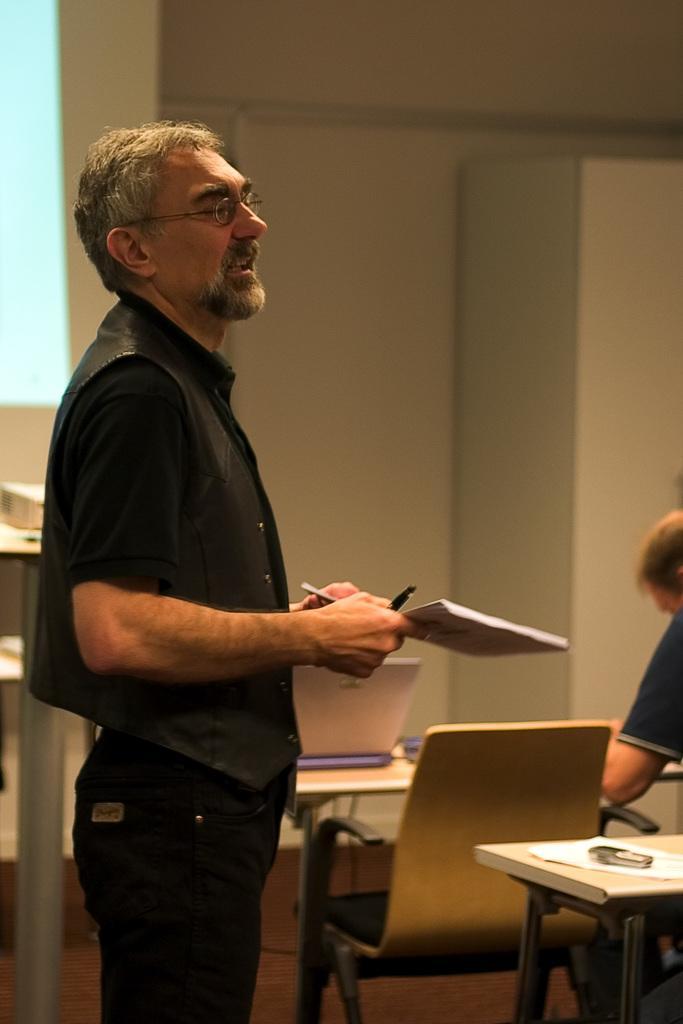Please provide a concise description of this image. In the left, a person is standing and holding a book in his hand and talking. In the right bottom, a person half visible. Next to that a table is there and chair is there on which paper is kept. The background wall is light cream in color. In the left top, a window is there through which sky is visible blue in color. This image is taken inside a room. 